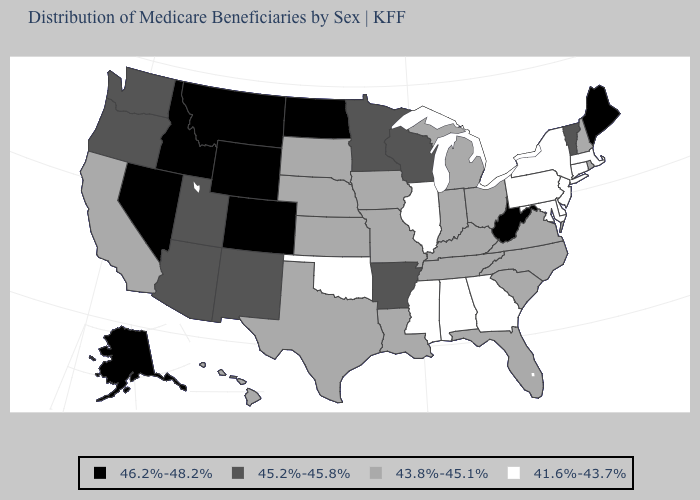What is the value of Colorado?
Quick response, please. 46.2%-48.2%. Name the states that have a value in the range 43.8%-45.1%?
Be succinct. California, Florida, Hawaii, Indiana, Iowa, Kansas, Kentucky, Louisiana, Michigan, Missouri, Nebraska, New Hampshire, North Carolina, Ohio, Rhode Island, South Carolina, South Dakota, Tennessee, Texas, Virginia. What is the value of Pennsylvania?
Give a very brief answer. 41.6%-43.7%. Name the states that have a value in the range 45.2%-45.8%?
Quick response, please. Arizona, Arkansas, Minnesota, New Mexico, Oregon, Utah, Vermont, Washington, Wisconsin. Which states have the lowest value in the USA?
Be succinct. Alabama, Connecticut, Delaware, Georgia, Illinois, Maryland, Massachusetts, Mississippi, New Jersey, New York, Oklahoma, Pennsylvania. What is the highest value in the USA?
Write a very short answer. 46.2%-48.2%. Name the states that have a value in the range 41.6%-43.7%?
Short answer required. Alabama, Connecticut, Delaware, Georgia, Illinois, Maryland, Massachusetts, Mississippi, New Jersey, New York, Oklahoma, Pennsylvania. What is the value of Vermont?
Concise answer only. 45.2%-45.8%. What is the lowest value in the USA?
Quick response, please. 41.6%-43.7%. Does the first symbol in the legend represent the smallest category?
Concise answer only. No. Does North Dakota have a lower value than South Carolina?
Short answer required. No. Among the states that border New Hampshire , does Massachusetts have the lowest value?
Answer briefly. Yes. What is the value of California?
Be succinct. 43.8%-45.1%. Does Connecticut have the highest value in the Northeast?
Concise answer only. No. Does the first symbol in the legend represent the smallest category?
Short answer required. No. 